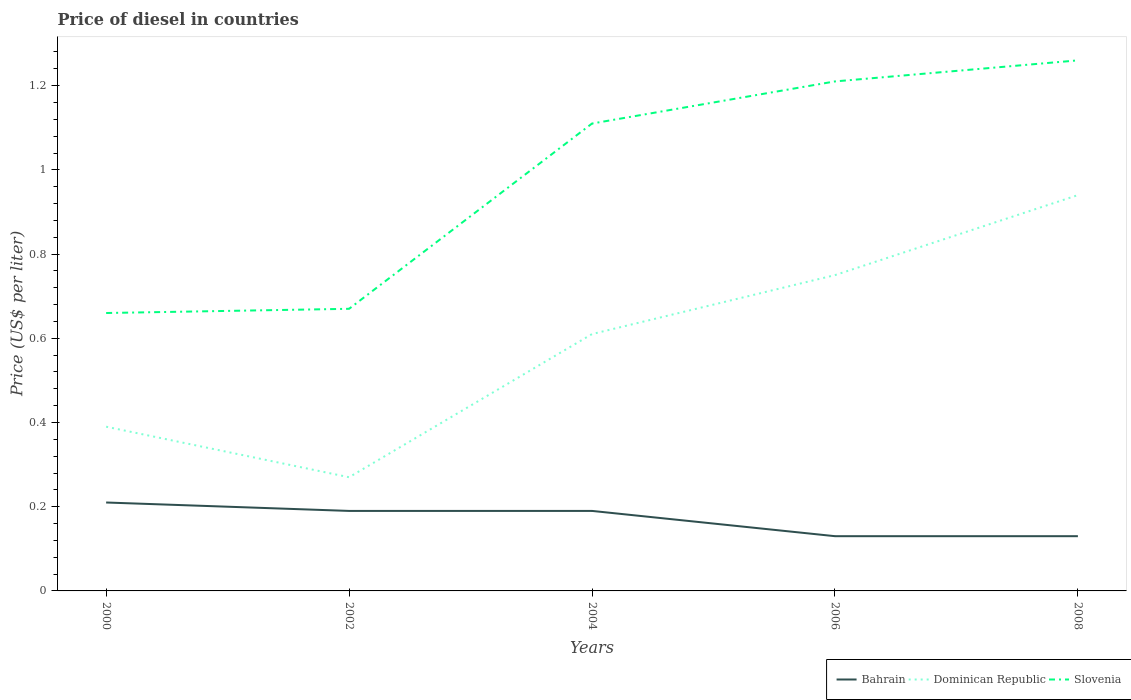How many different coloured lines are there?
Keep it short and to the point. 3. Across all years, what is the maximum price of diesel in Dominican Republic?
Ensure brevity in your answer.  0.27. What is the total price of diesel in Bahrain in the graph?
Your response must be concise. 0.06. What is the difference between the highest and the second highest price of diesel in Dominican Republic?
Make the answer very short. 0.67. How many lines are there?
Give a very brief answer. 3. What is the title of the graph?
Give a very brief answer. Price of diesel in countries. What is the label or title of the X-axis?
Provide a short and direct response. Years. What is the label or title of the Y-axis?
Make the answer very short. Price (US$ per liter). What is the Price (US$ per liter) in Bahrain in 2000?
Offer a terse response. 0.21. What is the Price (US$ per liter) in Dominican Republic in 2000?
Your response must be concise. 0.39. What is the Price (US$ per liter) of Slovenia in 2000?
Make the answer very short. 0.66. What is the Price (US$ per liter) of Bahrain in 2002?
Your response must be concise. 0.19. What is the Price (US$ per liter) of Dominican Republic in 2002?
Offer a terse response. 0.27. What is the Price (US$ per liter) in Slovenia in 2002?
Offer a terse response. 0.67. What is the Price (US$ per liter) of Bahrain in 2004?
Keep it short and to the point. 0.19. What is the Price (US$ per liter) in Dominican Republic in 2004?
Keep it short and to the point. 0.61. What is the Price (US$ per liter) in Slovenia in 2004?
Your response must be concise. 1.11. What is the Price (US$ per liter) in Bahrain in 2006?
Make the answer very short. 0.13. What is the Price (US$ per liter) of Slovenia in 2006?
Offer a very short reply. 1.21. What is the Price (US$ per liter) in Bahrain in 2008?
Your answer should be compact. 0.13. What is the Price (US$ per liter) of Slovenia in 2008?
Keep it short and to the point. 1.26. Across all years, what is the maximum Price (US$ per liter) in Bahrain?
Provide a short and direct response. 0.21. Across all years, what is the maximum Price (US$ per liter) of Slovenia?
Your response must be concise. 1.26. Across all years, what is the minimum Price (US$ per liter) in Bahrain?
Ensure brevity in your answer.  0.13. Across all years, what is the minimum Price (US$ per liter) of Dominican Republic?
Make the answer very short. 0.27. Across all years, what is the minimum Price (US$ per liter) of Slovenia?
Provide a succinct answer. 0.66. What is the total Price (US$ per liter) in Bahrain in the graph?
Offer a very short reply. 0.85. What is the total Price (US$ per liter) of Dominican Republic in the graph?
Make the answer very short. 2.96. What is the total Price (US$ per liter) of Slovenia in the graph?
Ensure brevity in your answer.  4.91. What is the difference between the Price (US$ per liter) in Dominican Republic in 2000 and that in 2002?
Your answer should be very brief. 0.12. What is the difference between the Price (US$ per liter) in Slovenia in 2000 and that in 2002?
Make the answer very short. -0.01. What is the difference between the Price (US$ per liter) in Bahrain in 2000 and that in 2004?
Give a very brief answer. 0.02. What is the difference between the Price (US$ per liter) in Dominican Republic in 2000 and that in 2004?
Provide a succinct answer. -0.22. What is the difference between the Price (US$ per liter) of Slovenia in 2000 and that in 2004?
Offer a very short reply. -0.45. What is the difference between the Price (US$ per liter) in Dominican Republic in 2000 and that in 2006?
Keep it short and to the point. -0.36. What is the difference between the Price (US$ per liter) in Slovenia in 2000 and that in 2006?
Offer a very short reply. -0.55. What is the difference between the Price (US$ per liter) in Dominican Republic in 2000 and that in 2008?
Your answer should be compact. -0.55. What is the difference between the Price (US$ per liter) of Dominican Republic in 2002 and that in 2004?
Your response must be concise. -0.34. What is the difference between the Price (US$ per liter) of Slovenia in 2002 and that in 2004?
Your answer should be very brief. -0.44. What is the difference between the Price (US$ per liter) in Bahrain in 2002 and that in 2006?
Offer a terse response. 0.06. What is the difference between the Price (US$ per liter) in Dominican Republic in 2002 and that in 2006?
Keep it short and to the point. -0.48. What is the difference between the Price (US$ per liter) of Slovenia in 2002 and that in 2006?
Your answer should be compact. -0.54. What is the difference between the Price (US$ per liter) in Dominican Republic in 2002 and that in 2008?
Provide a succinct answer. -0.67. What is the difference between the Price (US$ per liter) of Slovenia in 2002 and that in 2008?
Keep it short and to the point. -0.59. What is the difference between the Price (US$ per liter) of Dominican Republic in 2004 and that in 2006?
Provide a short and direct response. -0.14. What is the difference between the Price (US$ per liter) of Slovenia in 2004 and that in 2006?
Give a very brief answer. -0.1. What is the difference between the Price (US$ per liter) in Dominican Republic in 2004 and that in 2008?
Your response must be concise. -0.33. What is the difference between the Price (US$ per liter) of Slovenia in 2004 and that in 2008?
Your answer should be compact. -0.15. What is the difference between the Price (US$ per liter) of Bahrain in 2006 and that in 2008?
Give a very brief answer. 0. What is the difference between the Price (US$ per liter) of Dominican Republic in 2006 and that in 2008?
Offer a very short reply. -0.19. What is the difference between the Price (US$ per liter) of Slovenia in 2006 and that in 2008?
Provide a short and direct response. -0.05. What is the difference between the Price (US$ per liter) in Bahrain in 2000 and the Price (US$ per liter) in Dominican Republic in 2002?
Provide a succinct answer. -0.06. What is the difference between the Price (US$ per liter) in Bahrain in 2000 and the Price (US$ per liter) in Slovenia in 2002?
Provide a short and direct response. -0.46. What is the difference between the Price (US$ per liter) of Dominican Republic in 2000 and the Price (US$ per liter) of Slovenia in 2002?
Your answer should be very brief. -0.28. What is the difference between the Price (US$ per liter) in Bahrain in 2000 and the Price (US$ per liter) in Dominican Republic in 2004?
Ensure brevity in your answer.  -0.4. What is the difference between the Price (US$ per liter) of Dominican Republic in 2000 and the Price (US$ per liter) of Slovenia in 2004?
Give a very brief answer. -0.72. What is the difference between the Price (US$ per liter) in Bahrain in 2000 and the Price (US$ per liter) in Dominican Republic in 2006?
Provide a succinct answer. -0.54. What is the difference between the Price (US$ per liter) of Dominican Republic in 2000 and the Price (US$ per liter) of Slovenia in 2006?
Offer a very short reply. -0.82. What is the difference between the Price (US$ per liter) of Bahrain in 2000 and the Price (US$ per liter) of Dominican Republic in 2008?
Give a very brief answer. -0.73. What is the difference between the Price (US$ per liter) in Bahrain in 2000 and the Price (US$ per liter) in Slovenia in 2008?
Provide a short and direct response. -1.05. What is the difference between the Price (US$ per liter) in Dominican Republic in 2000 and the Price (US$ per liter) in Slovenia in 2008?
Offer a terse response. -0.87. What is the difference between the Price (US$ per liter) of Bahrain in 2002 and the Price (US$ per liter) of Dominican Republic in 2004?
Provide a succinct answer. -0.42. What is the difference between the Price (US$ per liter) of Bahrain in 2002 and the Price (US$ per liter) of Slovenia in 2004?
Offer a very short reply. -0.92. What is the difference between the Price (US$ per liter) in Dominican Republic in 2002 and the Price (US$ per liter) in Slovenia in 2004?
Offer a terse response. -0.84. What is the difference between the Price (US$ per liter) of Bahrain in 2002 and the Price (US$ per liter) of Dominican Republic in 2006?
Ensure brevity in your answer.  -0.56. What is the difference between the Price (US$ per liter) of Bahrain in 2002 and the Price (US$ per liter) of Slovenia in 2006?
Offer a very short reply. -1.02. What is the difference between the Price (US$ per liter) in Dominican Republic in 2002 and the Price (US$ per liter) in Slovenia in 2006?
Your answer should be very brief. -0.94. What is the difference between the Price (US$ per liter) in Bahrain in 2002 and the Price (US$ per liter) in Dominican Republic in 2008?
Your answer should be compact. -0.75. What is the difference between the Price (US$ per liter) in Bahrain in 2002 and the Price (US$ per liter) in Slovenia in 2008?
Keep it short and to the point. -1.07. What is the difference between the Price (US$ per liter) in Dominican Republic in 2002 and the Price (US$ per liter) in Slovenia in 2008?
Your answer should be compact. -0.99. What is the difference between the Price (US$ per liter) of Bahrain in 2004 and the Price (US$ per liter) of Dominican Republic in 2006?
Offer a very short reply. -0.56. What is the difference between the Price (US$ per liter) in Bahrain in 2004 and the Price (US$ per liter) in Slovenia in 2006?
Ensure brevity in your answer.  -1.02. What is the difference between the Price (US$ per liter) of Bahrain in 2004 and the Price (US$ per liter) of Dominican Republic in 2008?
Ensure brevity in your answer.  -0.75. What is the difference between the Price (US$ per liter) in Bahrain in 2004 and the Price (US$ per liter) in Slovenia in 2008?
Your answer should be compact. -1.07. What is the difference between the Price (US$ per liter) in Dominican Republic in 2004 and the Price (US$ per liter) in Slovenia in 2008?
Provide a succinct answer. -0.65. What is the difference between the Price (US$ per liter) in Bahrain in 2006 and the Price (US$ per liter) in Dominican Republic in 2008?
Make the answer very short. -0.81. What is the difference between the Price (US$ per liter) of Bahrain in 2006 and the Price (US$ per liter) of Slovenia in 2008?
Your answer should be compact. -1.13. What is the difference between the Price (US$ per liter) of Dominican Republic in 2006 and the Price (US$ per liter) of Slovenia in 2008?
Offer a terse response. -0.51. What is the average Price (US$ per liter) of Bahrain per year?
Offer a very short reply. 0.17. What is the average Price (US$ per liter) of Dominican Republic per year?
Keep it short and to the point. 0.59. What is the average Price (US$ per liter) in Slovenia per year?
Your response must be concise. 0.98. In the year 2000, what is the difference between the Price (US$ per liter) in Bahrain and Price (US$ per liter) in Dominican Republic?
Offer a very short reply. -0.18. In the year 2000, what is the difference between the Price (US$ per liter) in Bahrain and Price (US$ per liter) in Slovenia?
Provide a short and direct response. -0.45. In the year 2000, what is the difference between the Price (US$ per liter) of Dominican Republic and Price (US$ per liter) of Slovenia?
Your answer should be compact. -0.27. In the year 2002, what is the difference between the Price (US$ per liter) of Bahrain and Price (US$ per liter) of Dominican Republic?
Provide a succinct answer. -0.08. In the year 2002, what is the difference between the Price (US$ per liter) of Bahrain and Price (US$ per liter) of Slovenia?
Keep it short and to the point. -0.48. In the year 2004, what is the difference between the Price (US$ per liter) in Bahrain and Price (US$ per liter) in Dominican Republic?
Provide a succinct answer. -0.42. In the year 2004, what is the difference between the Price (US$ per liter) in Bahrain and Price (US$ per liter) in Slovenia?
Your answer should be compact. -0.92. In the year 2006, what is the difference between the Price (US$ per liter) in Bahrain and Price (US$ per liter) in Dominican Republic?
Offer a very short reply. -0.62. In the year 2006, what is the difference between the Price (US$ per liter) of Bahrain and Price (US$ per liter) of Slovenia?
Your response must be concise. -1.08. In the year 2006, what is the difference between the Price (US$ per liter) in Dominican Republic and Price (US$ per liter) in Slovenia?
Your response must be concise. -0.46. In the year 2008, what is the difference between the Price (US$ per liter) of Bahrain and Price (US$ per liter) of Dominican Republic?
Keep it short and to the point. -0.81. In the year 2008, what is the difference between the Price (US$ per liter) in Bahrain and Price (US$ per liter) in Slovenia?
Your answer should be compact. -1.13. In the year 2008, what is the difference between the Price (US$ per liter) of Dominican Republic and Price (US$ per liter) of Slovenia?
Give a very brief answer. -0.32. What is the ratio of the Price (US$ per liter) in Bahrain in 2000 to that in 2002?
Make the answer very short. 1.11. What is the ratio of the Price (US$ per liter) in Dominican Republic in 2000 to that in 2002?
Make the answer very short. 1.44. What is the ratio of the Price (US$ per liter) of Slovenia in 2000 to that in 2002?
Your answer should be very brief. 0.99. What is the ratio of the Price (US$ per liter) of Bahrain in 2000 to that in 2004?
Keep it short and to the point. 1.11. What is the ratio of the Price (US$ per liter) in Dominican Republic in 2000 to that in 2004?
Your response must be concise. 0.64. What is the ratio of the Price (US$ per liter) in Slovenia in 2000 to that in 2004?
Provide a short and direct response. 0.59. What is the ratio of the Price (US$ per liter) of Bahrain in 2000 to that in 2006?
Your answer should be very brief. 1.62. What is the ratio of the Price (US$ per liter) of Dominican Republic in 2000 to that in 2006?
Make the answer very short. 0.52. What is the ratio of the Price (US$ per liter) in Slovenia in 2000 to that in 2006?
Your answer should be compact. 0.55. What is the ratio of the Price (US$ per liter) in Bahrain in 2000 to that in 2008?
Ensure brevity in your answer.  1.62. What is the ratio of the Price (US$ per liter) in Dominican Republic in 2000 to that in 2008?
Provide a short and direct response. 0.41. What is the ratio of the Price (US$ per liter) of Slovenia in 2000 to that in 2008?
Make the answer very short. 0.52. What is the ratio of the Price (US$ per liter) in Dominican Republic in 2002 to that in 2004?
Your answer should be compact. 0.44. What is the ratio of the Price (US$ per liter) of Slovenia in 2002 to that in 2004?
Provide a short and direct response. 0.6. What is the ratio of the Price (US$ per liter) in Bahrain in 2002 to that in 2006?
Keep it short and to the point. 1.46. What is the ratio of the Price (US$ per liter) in Dominican Republic in 2002 to that in 2006?
Make the answer very short. 0.36. What is the ratio of the Price (US$ per liter) of Slovenia in 2002 to that in 2006?
Ensure brevity in your answer.  0.55. What is the ratio of the Price (US$ per liter) of Bahrain in 2002 to that in 2008?
Offer a very short reply. 1.46. What is the ratio of the Price (US$ per liter) in Dominican Republic in 2002 to that in 2008?
Provide a succinct answer. 0.29. What is the ratio of the Price (US$ per liter) in Slovenia in 2002 to that in 2008?
Offer a terse response. 0.53. What is the ratio of the Price (US$ per liter) of Bahrain in 2004 to that in 2006?
Offer a very short reply. 1.46. What is the ratio of the Price (US$ per liter) in Dominican Republic in 2004 to that in 2006?
Your answer should be compact. 0.81. What is the ratio of the Price (US$ per liter) in Slovenia in 2004 to that in 2006?
Offer a terse response. 0.92. What is the ratio of the Price (US$ per liter) of Bahrain in 2004 to that in 2008?
Make the answer very short. 1.46. What is the ratio of the Price (US$ per liter) of Dominican Republic in 2004 to that in 2008?
Provide a succinct answer. 0.65. What is the ratio of the Price (US$ per liter) in Slovenia in 2004 to that in 2008?
Your response must be concise. 0.88. What is the ratio of the Price (US$ per liter) of Dominican Republic in 2006 to that in 2008?
Your answer should be compact. 0.8. What is the ratio of the Price (US$ per liter) in Slovenia in 2006 to that in 2008?
Your answer should be very brief. 0.96. What is the difference between the highest and the second highest Price (US$ per liter) of Dominican Republic?
Keep it short and to the point. 0.19. What is the difference between the highest and the second highest Price (US$ per liter) in Slovenia?
Give a very brief answer. 0.05. What is the difference between the highest and the lowest Price (US$ per liter) in Dominican Republic?
Ensure brevity in your answer.  0.67. What is the difference between the highest and the lowest Price (US$ per liter) of Slovenia?
Provide a succinct answer. 0.6. 